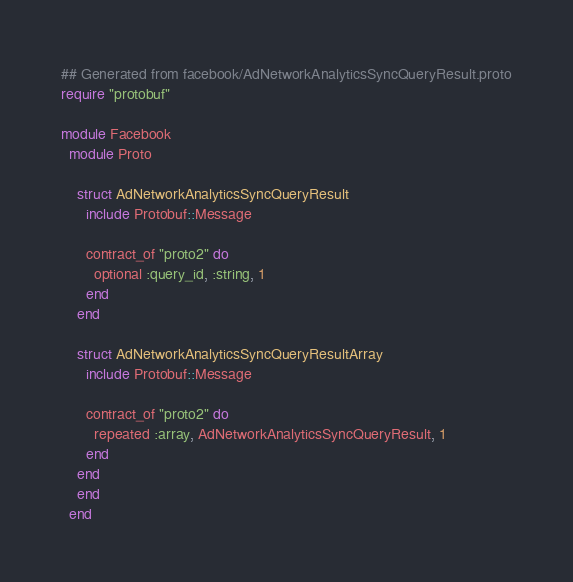<code> <loc_0><loc_0><loc_500><loc_500><_Crystal_>## Generated from facebook/AdNetworkAnalyticsSyncQueryResult.proto
require "protobuf"

module Facebook
  module Proto
    
    struct AdNetworkAnalyticsSyncQueryResult
      include Protobuf::Message
      
      contract_of "proto2" do
        optional :query_id, :string, 1
      end
    end
    
    struct AdNetworkAnalyticsSyncQueryResultArray
      include Protobuf::Message
      
      contract_of "proto2" do
        repeated :array, AdNetworkAnalyticsSyncQueryResult, 1
      end
    end
    end
  end
</code> 